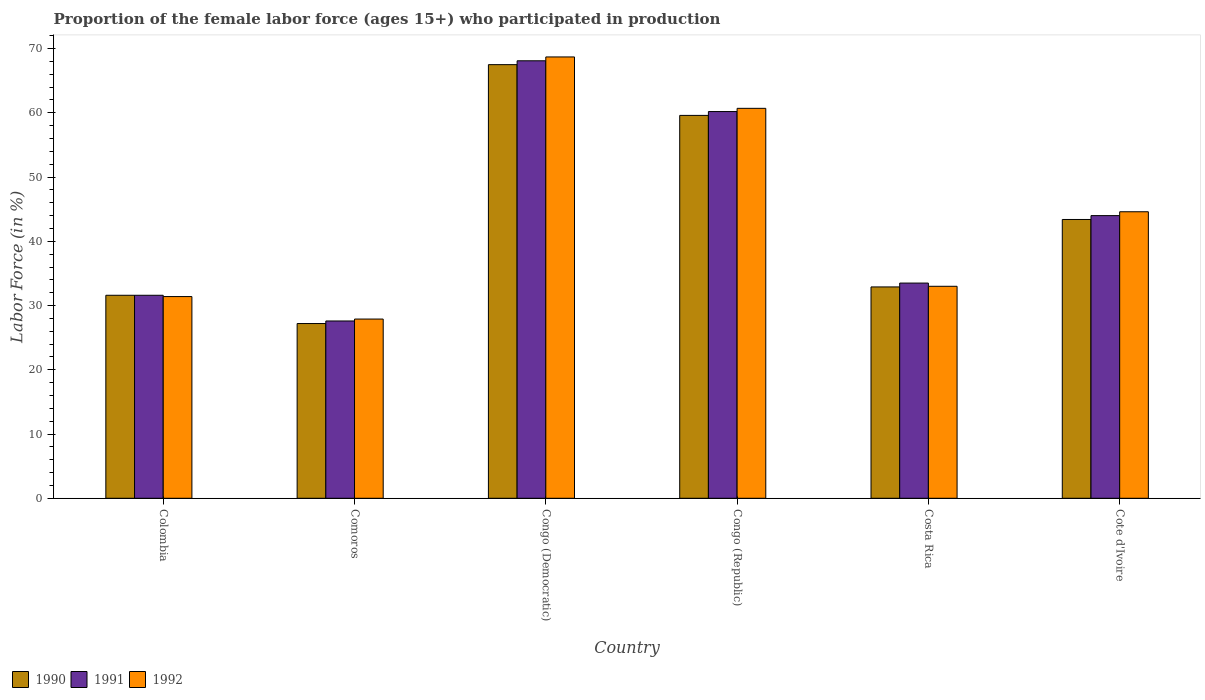How many groups of bars are there?
Give a very brief answer. 6. Are the number of bars on each tick of the X-axis equal?
Ensure brevity in your answer.  Yes. How many bars are there on the 5th tick from the right?
Make the answer very short. 3. What is the label of the 4th group of bars from the left?
Keep it short and to the point. Congo (Republic). What is the proportion of the female labor force who participated in production in 1990 in Congo (Republic)?
Ensure brevity in your answer.  59.6. Across all countries, what is the maximum proportion of the female labor force who participated in production in 1991?
Ensure brevity in your answer.  68.1. Across all countries, what is the minimum proportion of the female labor force who participated in production in 1991?
Your answer should be compact. 27.6. In which country was the proportion of the female labor force who participated in production in 1991 maximum?
Your response must be concise. Congo (Democratic). In which country was the proportion of the female labor force who participated in production in 1992 minimum?
Keep it short and to the point. Comoros. What is the total proportion of the female labor force who participated in production in 1990 in the graph?
Offer a terse response. 262.2. What is the difference between the proportion of the female labor force who participated in production in 1992 in Comoros and that in Congo (Republic)?
Ensure brevity in your answer.  -32.8. What is the difference between the proportion of the female labor force who participated in production in 1991 in Cote d'Ivoire and the proportion of the female labor force who participated in production in 1992 in Congo (Republic)?
Your response must be concise. -16.7. What is the average proportion of the female labor force who participated in production in 1991 per country?
Make the answer very short. 44.17. What is the difference between the proportion of the female labor force who participated in production of/in 1990 and proportion of the female labor force who participated in production of/in 1991 in Cote d'Ivoire?
Offer a very short reply. -0.6. What is the ratio of the proportion of the female labor force who participated in production in 1992 in Colombia to that in Congo (Democratic)?
Your answer should be very brief. 0.46. What is the difference between the highest and the second highest proportion of the female labor force who participated in production in 1991?
Give a very brief answer. 7.9. What is the difference between the highest and the lowest proportion of the female labor force who participated in production in 1990?
Provide a succinct answer. 40.3. In how many countries, is the proportion of the female labor force who participated in production in 1992 greater than the average proportion of the female labor force who participated in production in 1992 taken over all countries?
Keep it short and to the point. 3. What does the 3rd bar from the left in Comoros represents?
Provide a short and direct response. 1992. How many bars are there?
Offer a very short reply. 18. Are all the bars in the graph horizontal?
Your answer should be compact. No. What is the difference between two consecutive major ticks on the Y-axis?
Offer a terse response. 10. Are the values on the major ticks of Y-axis written in scientific E-notation?
Provide a short and direct response. No. Does the graph contain any zero values?
Keep it short and to the point. No. Does the graph contain grids?
Give a very brief answer. No. Where does the legend appear in the graph?
Provide a short and direct response. Bottom left. How are the legend labels stacked?
Make the answer very short. Horizontal. What is the title of the graph?
Provide a short and direct response. Proportion of the female labor force (ages 15+) who participated in production. What is the Labor Force (in %) in 1990 in Colombia?
Keep it short and to the point. 31.6. What is the Labor Force (in %) in 1991 in Colombia?
Give a very brief answer. 31.6. What is the Labor Force (in %) in 1992 in Colombia?
Provide a succinct answer. 31.4. What is the Labor Force (in %) in 1990 in Comoros?
Ensure brevity in your answer.  27.2. What is the Labor Force (in %) of 1991 in Comoros?
Keep it short and to the point. 27.6. What is the Labor Force (in %) of 1992 in Comoros?
Give a very brief answer. 27.9. What is the Labor Force (in %) in 1990 in Congo (Democratic)?
Make the answer very short. 67.5. What is the Labor Force (in %) in 1991 in Congo (Democratic)?
Your response must be concise. 68.1. What is the Labor Force (in %) in 1992 in Congo (Democratic)?
Ensure brevity in your answer.  68.7. What is the Labor Force (in %) in 1990 in Congo (Republic)?
Ensure brevity in your answer.  59.6. What is the Labor Force (in %) of 1991 in Congo (Republic)?
Give a very brief answer. 60.2. What is the Labor Force (in %) of 1992 in Congo (Republic)?
Make the answer very short. 60.7. What is the Labor Force (in %) of 1990 in Costa Rica?
Offer a terse response. 32.9. What is the Labor Force (in %) in 1991 in Costa Rica?
Your response must be concise. 33.5. What is the Labor Force (in %) in 1992 in Costa Rica?
Your response must be concise. 33. What is the Labor Force (in %) in 1990 in Cote d'Ivoire?
Provide a short and direct response. 43.4. What is the Labor Force (in %) of 1991 in Cote d'Ivoire?
Your answer should be very brief. 44. What is the Labor Force (in %) in 1992 in Cote d'Ivoire?
Offer a very short reply. 44.6. Across all countries, what is the maximum Labor Force (in %) of 1990?
Your response must be concise. 67.5. Across all countries, what is the maximum Labor Force (in %) of 1991?
Provide a short and direct response. 68.1. Across all countries, what is the maximum Labor Force (in %) of 1992?
Your answer should be very brief. 68.7. Across all countries, what is the minimum Labor Force (in %) in 1990?
Ensure brevity in your answer.  27.2. Across all countries, what is the minimum Labor Force (in %) in 1991?
Keep it short and to the point. 27.6. Across all countries, what is the minimum Labor Force (in %) of 1992?
Give a very brief answer. 27.9. What is the total Labor Force (in %) in 1990 in the graph?
Provide a succinct answer. 262.2. What is the total Labor Force (in %) of 1991 in the graph?
Offer a very short reply. 265. What is the total Labor Force (in %) of 1992 in the graph?
Your answer should be compact. 266.3. What is the difference between the Labor Force (in %) in 1992 in Colombia and that in Comoros?
Offer a very short reply. 3.5. What is the difference between the Labor Force (in %) of 1990 in Colombia and that in Congo (Democratic)?
Ensure brevity in your answer.  -35.9. What is the difference between the Labor Force (in %) of 1991 in Colombia and that in Congo (Democratic)?
Your response must be concise. -36.5. What is the difference between the Labor Force (in %) of 1992 in Colombia and that in Congo (Democratic)?
Ensure brevity in your answer.  -37.3. What is the difference between the Labor Force (in %) in 1990 in Colombia and that in Congo (Republic)?
Offer a very short reply. -28. What is the difference between the Labor Force (in %) of 1991 in Colombia and that in Congo (Republic)?
Give a very brief answer. -28.6. What is the difference between the Labor Force (in %) of 1992 in Colombia and that in Congo (Republic)?
Your answer should be very brief. -29.3. What is the difference between the Labor Force (in %) of 1990 in Colombia and that in Costa Rica?
Offer a very short reply. -1.3. What is the difference between the Labor Force (in %) in 1991 in Colombia and that in Costa Rica?
Keep it short and to the point. -1.9. What is the difference between the Labor Force (in %) of 1990 in Comoros and that in Congo (Democratic)?
Provide a short and direct response. -40.3. What is the difference between the Labor Force (in %) in 1991 in Comoros and that in Congo (Democratic)?
Offer a very short reply. -40.5. What is the difference between the Labor Force (in %) of 1992 in Comoros and that in Congo (Democratic)?
Make the answer very short. -40.8. What is the difference between the Labor Force (in %) in 1990 in Comoros and that in Congo (Republic)?
Give a very brief answer. -32.4. What is the difference between the Labor Force (in %) in 1991 in Comoros and that in Congo (Republic)?
Your answer should be compact. -32.6. What is the difference between the Labor Force (in %) in 1992 in Comoros and that in Congo (Republic)?
Your response must be concise. -32.8. What is the difference between the Labor Force (in %) of 1992 in Comoros and that in Costa Rica?
Provide a succinct answer. -5.1. What is the difference between the Labor Force (in %) of 1990 in Comoros and that in Cote d'Ivoire?
Make the answer very short. -16.2. What is the difference between the Labor Force (in %) of 1991 in Comoros and that in Cote d'Ivoire?
Give a very brief answer. -16.4. What is the difference between the Labor Force (in %) in 1992 in Comoros and that in Cote d'Ivoire?
Offer a terse response. -16.7. What is the difference between the Labor Force (in %) of 1990 in Congo (Democratic) and that in Congo (Republic)?
Give a very brief answer. 7.9. What is the difference between the Labor Force (in %) in 1991 in Congo (Democratic) and that in Congo (Republic)?
Ensure brevity in your answer.  7.9. What is the difference between the Labor Force (in %) in 1990 in Congo (Democratic) and that in Costa Rica?
Keep it short and to the point. 34.6. What is the difference between the Labor Force (in %) in 1991 in Congo (Democratic) and that in Costa Rica?
Make the answer very short. 34.6. What is the difference between the Labor Force (in %) of 1992 in Congo (Democratic) and that in Costa Rica?
Provide a short and direct response. 35.7. What is the difference between the Labor Force (in %) of 1990 in Congo (Democratic) and that in Cote d'Ivoire?
Your answer should be very brief. 24.1. What is the difference between the Labor Force (in %) of 1991 in Congo (Democratic) and that in Cote d'Ivoire?
Offer a terse response. 24.1. What is the difference between the Labor Force (in %) in 1992 in Congo (Democratic) and that in Cote d'Ivoire?
Make the answer very short. 24.1. What is the difference between the Labor Force (in %) of 1990 in Congo (Republic) and that in Costa Rica?
Your answer should be very brief. 26.7. What is the difference between the Labor Force (in %) in 1991 in Congo (Republic) and that in Costa Rica?
Keep it short and to the point. 26.7. What is the difference between the Labor Force (in %) of 1992 in Congo (Republic) and that in Costa Rica?
Offer a very short reply. 27.7. What is the difference between the Labor Force (in %) of 1991 in Congo (Republic) and that in Cote d'Ivoire?
Your answer should be compact. 16.2. What is the difference between the Labor Force (in %) of 1990 in Costa Rica and that in Cote d'Ivoire?
Your response must be concise. -10.5. What is the difference between the Labor Force (in %) in 1990 in Colombia and the Labor Force (in %) in 1991 in Comoros?
Provide a succinct answer. 4. What is the difference between the Labor Force (in %) of 1991 in Colombia and the Labor Force (in %) of 1992 in Comoros?
Give a very brief answer. 3.7. What is the difference between the Labor Force (in %) in 1990 in Colombia and the Labor Force (in %) in 1991 in Congo (Democratic)?
Provide a short and direct response. -36.5. What is the difference between the Labor Force (in %) in 1990 in Colombia and the Labor Force (in %) in 1992 in Congo (Democratic)?
Give a very brief answer. -37.1. What is the difference between the Labor Force (in %) in 1991 in Colombia and the Labor Force (in %) in 1992 in Congo (Democratic)?
Give a very brief answer. -37.1. What is the difference between the Labor Force (in %) of 1990 in Colombia and the Labor Force (in %) of 1991 in Congo (Republic)?
Provide a succinct answer. -28.6. What is the difference between the Labor Force (in %) of 1990 in Colombia and the Labor Force (in %) of 1992 in Congo (Republic)?
Your response must be concise. -29.1. What is the difference between the Labor Force (in %) of 1991 in Colombia and the Labor Force (in %) of 1992 in Congo (Republic)?
Provide a short and direct response. -29.1. What is the difference between the Labor Force (in %) in 1990 in Colombia and the Labor Force (in %) in 1991 in Costa Rica?
Ensure brevity in your answer.  -1.9. What is the difference between the Labor Force (in %) in 1991 in Colombia and the Labor Force (in %) in 1992 in Costa Rica?
Offer a very short reply. -1.4. What is the difference between the Labor Force (in %) of 1991 in Colombia and the Labor Force (in %) of 1992 in Cote d'Ivoire?
Offer a very short reply. -13. What is the difference between the Labor Force (in %) of 1990 in Comoros and the Labor Force (in %) of 1991 in Congo (Democratic)?
Offer a terse response. -40.9. What is the difference between the Labor Force (in %) in 1990 in Comoros and the Labor Force (in %) in 1992 in Congo (Democratic)?
Provide a succinct answer. -41.5. What is the difference between the Labor Force (in %) of 1991 in Comoros and the Labor Force (in %) of 1992 in Congo (Democratic)?
Keep it short and to the point. -41.1. What is the difference between the Labor Force (in %) in 1990 in Comoros and the Labor Force (in %) in 1991 in Congo (Republic)?
Your response must be concise. -33. What is the difference between the Labor Force (in %) in 1990 in Comoros and the Labor Force (in %) in 1992 in Congo (Republic)?
Provide a short and direct response. -33.5. What is the difference between the Labor Force (in %) of 1991 in Comoros and the Labor Force (in %) of 1992 in Congo (Republic)?
Offer a terse response. -33.1. What is the difference between the Labor Force (in %) in 1990 in Comoros and the Labor Force (in %) in 1992 in Costa Rica?
Ensure brevity in your answer.  -5.8. What is the difference between the Labor Force (in %) in 1990 in Comoros and the Labor Force (in %) in 1991 in Cote d'Ivoire?
Give a very brief answer. -16.8. What is the difference between the Labor Force (in %) of 1990 in Comoros and the Labor Force (in %) of 1992 in Cote d'Ivoire?
Your response must be concise. -17.4. What is the difference between the Labor Force (in %) in 1991 in Comoros and the Labor Force (in %) in 1992 in Cote d'Ivoire?
Offer a terse response. -17. What is the difference between the Labor Force (in %) in 1990 in Congo (Democratic) and the Labor Force (in %) in 1991 in Costa Rica?
Offer a terse response. 34. What is the difference between the Labor Force (in %) of 1990 in Congo (Democratic) and the Labor Force (in %) of 1992 in Costa Rica?
Give a very brief answer. 34.5. What is the difference between the Labor Force (in %) of 1991 in Congo (Democratic) and the Labor Force (in %) of 1992 in Costa Rica?
Your answer should be compact. 35.1. What is the difference between the Labor Force (in %) in 1990 in Congo (Democratic) and the Labor Force (in %) in 1992 in Cote d'Ivoire?
Offer a terse response. 22.9. What is the difference between the Labor Force (in %) of 1990 in Congo (Republic) and the Labor Force (in %) of 1991 in Costa Rica?
Your answer should be very brief. 26.1. What is the difference between the Labor Force (in %) in 1990 in Congo (Republic) and the Labor Force (in %) in 1992 in Costa Rica?
Offer a terse response. 26.6. What is the difference between the Labor Force (in %) in 1991 in Congo (Republic) and the Labor Force (in %) in 1992 in Costa Rica?
Your answer should be compact. 27.2. What is the difference between the Labor Force (in %) of 1990 in Congo (Republic) and the Labor Force (in %) of 1991 in Cote d'Ivoire?
Your response must be concise. 15.6. What is the average Labor Force (in %) of 1990 per country?
Give a very brief answer. 43.7. What is the average Labor Force (in %) of 1991 per country?
Your answer should be compact. 44.17. What is the average Labor Force (in %) of 1992 per country?
Your response must be concise. 44.38. What is the difference between the Labor Force (in %) in 1990 and Labor Force (in %) in 1992 in Colombia?
Provide a succinct answer. 0.2. What is the difference between the Labor Force (in %) in 1991 and Labor Force (in %) in 1992 in Colombia?
Provide a succinct answer. 0.2. What is the difference between the Labor Force (in %) in 1990 and Labor Force (in %) in 1992 in Comoros?
Keep it short and to the point. -0.7. What is the difference between the Labor Force (in %) in 1991 and Labor Force (in %) in 1992 in Comoros?
Make the answer very short. -0.3. What is the difference between the Labor Force (in %) of 1990 and Labor Force (in %) of 1991 in Congo (Democratic)?
Give a very brief answer. -0.6. What is the difference between the Labor Force (in %) of 1991 and Labor Force (in %) of 1992 in Congo (Democratic)?
Keep it short and to the point. -0.6. What is the difference between the Labor Force (in %) of 1990 and Labor Force (in %) of 1992 in Congo (Republic)?
Offer a terse response. -1.1. What is the difference between the Labor Force (in %) in 1991 and Labor Force (in %) in 1992 in Congo (Republic)?
Your response must be concise. -0.5. What is the difference between the Labor Force (in %) in 1990 and Labor Force (in %) in 1991 in Costa Rica?
Make the answer very short. -0.6. What is the difference between the Labor Force (in %) in 1990 and Labor Force (in %) in 1992 in Costa Rica?
Provide a succinct answer. -0.1. What is the difference between the Labor Force (in %) of 1990 and Labor Force (in %) of 1991 in Cote d'Ivoire?
Give a very brief answer. -0.6. What is the ratio of the Labor Force (in %) in 1990 in Colombia to that in Comoros?
Your response must be concise. 1.16. What is the ratio of the Labor Force (in %) in 1991 in Colombia to that in Comoros?
Ensure brevity in your answer.  1.14. What is the ratio of the Labor Force (in %) of 1992 in Colombia to that in Comoros?
Ensure brevity in your answer.  1.13. What is the ratio of the Labor Force (in %) of 1990 in Colombia to that in Congo (Democratic)?
Give a very brief answer. 0.47. What is the ratio of the Labor Force (in %) of 1991 in Colombia to that in Congo (Democratic)?
Offer a terse response. 0.46. What is the ratio of the Labor Force (in %) of 1992 in Colombia to that in Congo (Democratic)?
Provide a succinct answer. 0.46. What is the ratio of the Labor Force (in %) of 1990 in Colombia to that in Congo (Republic)?
Give a very brief answer. 0.53. What is the ratio of the Labor Force (in %) of 1991 in Colombia to that in Congo (Republic)?
Ensure brevity in your answer.  0.52. What is the ratio of the Labor Force (in %) in 1992 in Colombia to that in Congo (Republic)?
Provide a short and direct response. 0.52. What is the ratio of the Labor Force (in %) of 1990 in Colombia to that in Costa Rica?
Your answer should be compact. 0.96. What is the ratio of the Labor Force (in %) of 1991 in Colombia to that in Costa Rica?
Keep it short and to the point. 0.94. What is the ratio of the Labor Force (in %) in 1992 in Colombia to that in Costa Rica?
Offer a very short reply. 0.95. What is the ratio of the Labor Force (in %) in 1990 in Colombia to that in Cote d'Ivoire?
Your answer should be compact. 0.73. What is the ratio of the Labor Force (in %) of 1991 in Colombia to that in Cote d'Ivoire?
Offer a very short reply. 0.72. What is the ratio of the Labor Force (in %) of 1992 in Colombia to that in Cote d'Ivoire?
Ensure brevity in your answer.  0.7. What is the ratio of the Labor Force (in %) in 1990 in Comoros to that in Congo (Democratic)?
Provide a short and direct response. 0.4. What is the ratio of the Labor Force (in %) in 1991 in Comoros to that in Congo (Democratic)?
Your response must be concise. 0.41. What is the ratio of the Labor Force (in %) of 1992 in Comoros to that in Congo (Democratic)?
Ensure brevity in your answer.  0.41. What is the ratio of the Labor Force (in %) in 1990 in Comoros to that in Congo (Republic)?
Provide a succinct answer. 0.46. What is the ratio of the Labor Force (in %) in 1991 in Comoros to that in Congo (Republic)?
Your response must be concise. 0.46. What is the ratio of the Labor Force (in %) in 1992 in Comoros to that in Congo (Republic)?
Your answer should be very brief. 0.46. What is the ratio of the Labor Force (in %) in 1990 in Comoros to that in Costa Rica?
Offer a terse response. 0.83. What is the ratio of the Labor Force (in %) in 1991 in Comoros to that in Costa Rica?
Provide a succinct answer. 0.82. What is the ratio of the Labor Force (in %) of 1992 in Comoros to that in Costa Rica?
Make the answer very short. 0.85. What is the ratio of the Labor Force (in %) in 1990 in Comoros to that in Cote d'Ivoire?
Provide a short and direct response. 0.63. What is the ratio of the Labor Force (in %) of 1991 in Comoros to that in Cote d'Ivoire?
Your answer should be very brief. 0.63. What is the ratio of the Labor Force (in %) of 1992 in Comoros to that in Cote d'Ivoire?
Offer a terse response. 0.63. What is the ratio of the Labor Force (in %) in 1990 in Congo (Democratic) to that in Congo (Republic)?
Your answer should be compact. 1.13. What is the ratio of the Labor Force (in %) in 1991 in Congo (Democratic) to that in Congo (Republic)?
Offer a terse response. 1.13. What is the ratio of the Labor Force (in %) in 1992 in Congo (Democratic) to that in Congo (Republic)?
Give a very brief answer. 1.13. What is the ratio of the Labor Force (in %) of 1990 in Congo (Democratic) to that in Costa Rica?
Your response must be concise. 2.05. What is the ratio of the Labor Force (in %) of 1991 in Congo (Democratic) to that in Costa Rica?
Make the answer very short. 2.03. What is the ratio of the Labor Force (in %) in 1992 in Congo (Democratic) to that in Costa Rica?
Your answer should be compact. 2.08. What is the ratio of the Labor Force (in %) of 1990 in Congo (Democratic) to that in Cote d'Ivoire?
Give a very brief answer. 1.56. What is the ratio of the Labor Force (in %) of 1991 in Congo (Democratic) to that in Cote d'Ivoire?
Make the answer very short. 1.55. What is the ratio of the Labor Force (in %) in 1992 in Congo (Democratic) to that in Cote d'Ivoire?
Offer a terse response. 1.54. What is the ratio of the Labor Force (in %) of 1990 in Congo (Republic) to that in Costa Rica?
Ensure brevity in your answer.  1.81. What is the ratio of the Labor Force (in %) in 1991 in Congo (Republic) to that in Costa Rica?
Keep it short and to the point. 1.8. What is the ratio of the Labor Force (in %) of 1992 in Congo (Republic) to that in Costa Rica?
Keep it short and to the point. 1.84. What is the ratio of the Labor Force (in %) in 1990 in Congo (Republic) to that in Cote d'Ivoire?
Provide a succinct answer. 1.37. What is the ratio of the Labor Force (in %) in 1991 in Congo (Republic) to that in Cote d'Ivoire?
Give a very brief answer. 1.37. What is the ratio of the Labor Force (in %) in 1992 in Congo (Republic) to that in Cote d'Ivoire?
Provide a succinct answer. 1.36. What is the ratio of the Labor Force (in %) in 1990 in Costa Rica to that in Cote d'Ivoire?
Your answer should be compact. 0.76. What is the ratio of the Labor Force (in %) of 1991 in Costa Rica to that in Cote d'Ivoire?
Give a very brief answer. 0.76. What is the ratio of the Labor Force (in %) in 1992 in Costa Rica to that in Cote d'Ivoire?
Your response must be concise. 0.74. What is the difference between the highest and the second highest Labor Force (in %) in 1991?
Your answer should be compact. 7.9. What is the difference between the highest and the lowest Labor Force (in %) of 1990?
Give a very brief answer. 40.3. What is the difference between the highest and the lowest Labor Force (in %) of 1991?
Offer a terse response. 40.5. What is the difference between the highest and the lowest Labor Force (in %) of 1992?
Make the answer very short. 40.8. 